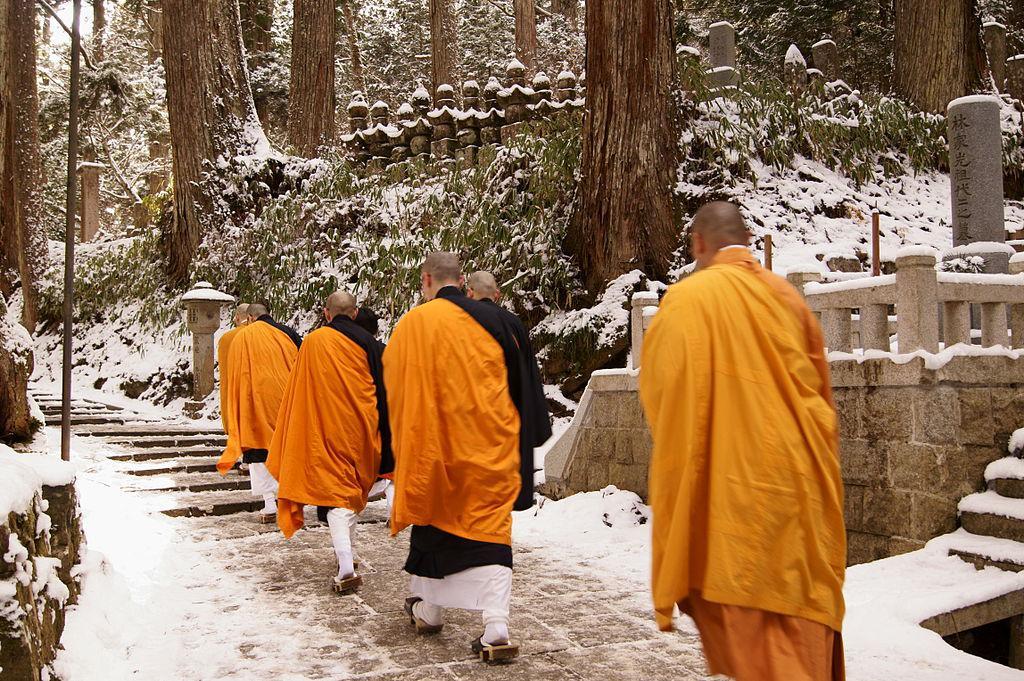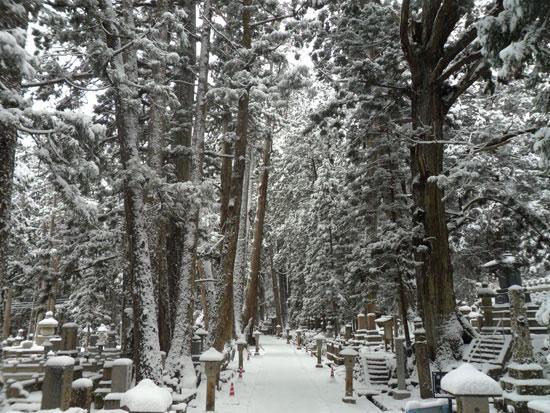The first image is the image on the left, the second image is the image on the right. Analyze the images presented: Is the assertion "An image shows at least three people in golden-yellow robes walking in a snowy scene." valid? Answer yes or no. Yes. The first image is the image on the left, the second image is the image on the right. Evaluate the accuracy of this statement regarding the images: "The red posts of a Buddhist shrine can be seen in one image, while a single monk walks on a stone path in the other image.". Is it true? Answer yes or no. No. 